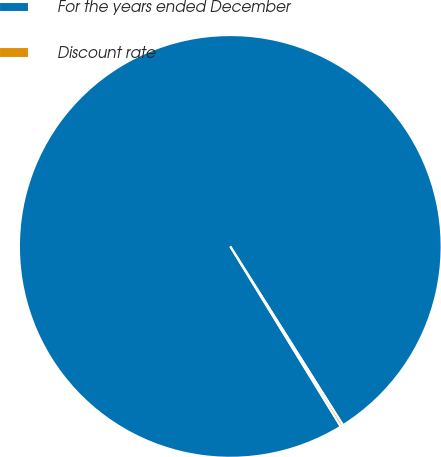Convert chart to OTSL. <chart><loc_0><loc_0><loc_500><loc_500><pie_chart><fcel>For the years ended December<fcel>Discount rate<nl><fcel>99.8%<fcel>0.2%<nl></chart> 